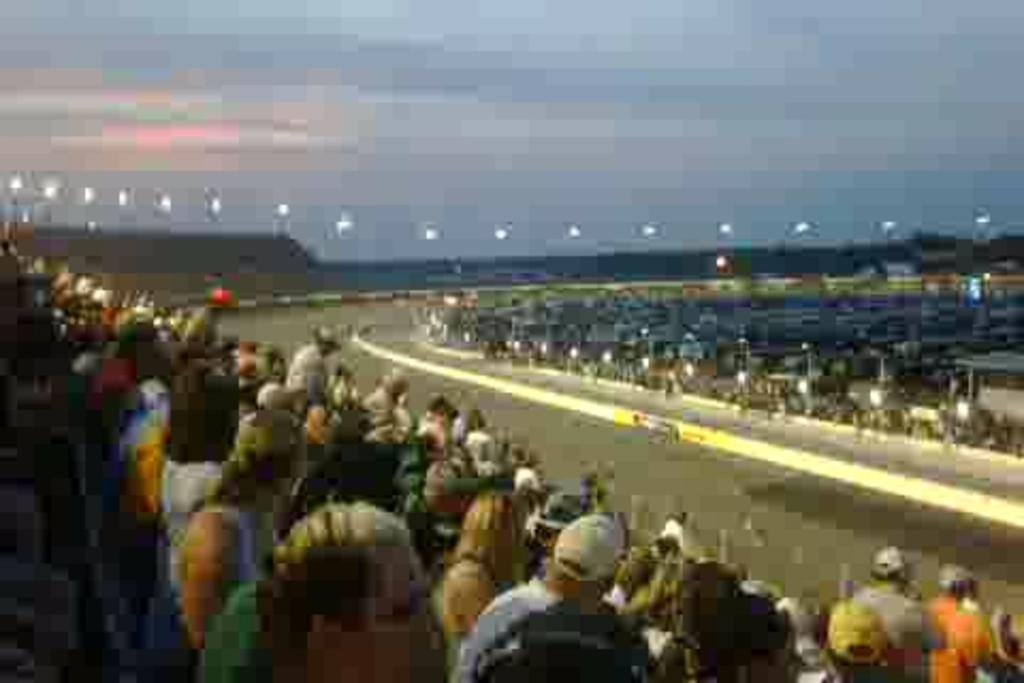What is located in the front of the image? There are persons in the front of the image. What can be seen in the center of the image? There is a road in the center of the image. How would you describe the background of the image? The background of the image is blurry. What type of house can be seen in the background of the image? There is no house visible in the background of the image; it is blurry and does not show any specific structures. 